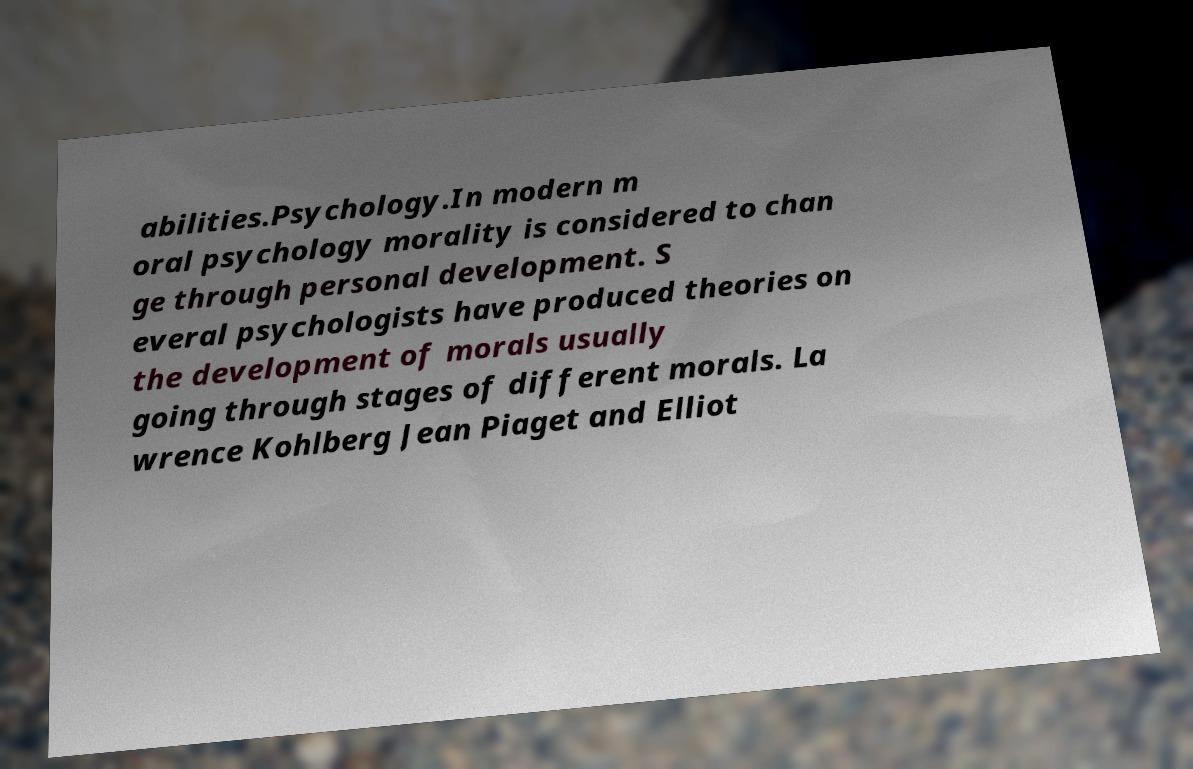Could you extract and type out the text from this image? abilities.Psychology.In modern m oral psychology morality is considered to chan ge through personal development. S everal psychologists have produced theories on the development of morals usually going through stages of different morals. La wrence Kohlberg Jean Piaget and Elliot 